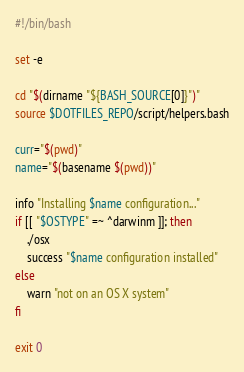Convert code to text. <code><loc_0><loc_0><loc_500><loc_500><_Bash_>#!/bin/bash

set -e

cd "$(dirname "${BASH_SOURCE[0]}")"
source $DOTFILES_REPO/script/helpers.bash

curr="$(pwd)"
name="$(basename $(pwd))"

info "Installing $name configuration..."
if [[ "$OSTYPE" =~ ^darwinm ]]; then
	./osx
	success "$name configuration installed"
else
	warn "not on an OS X system"
fi

exit 0
</code> 